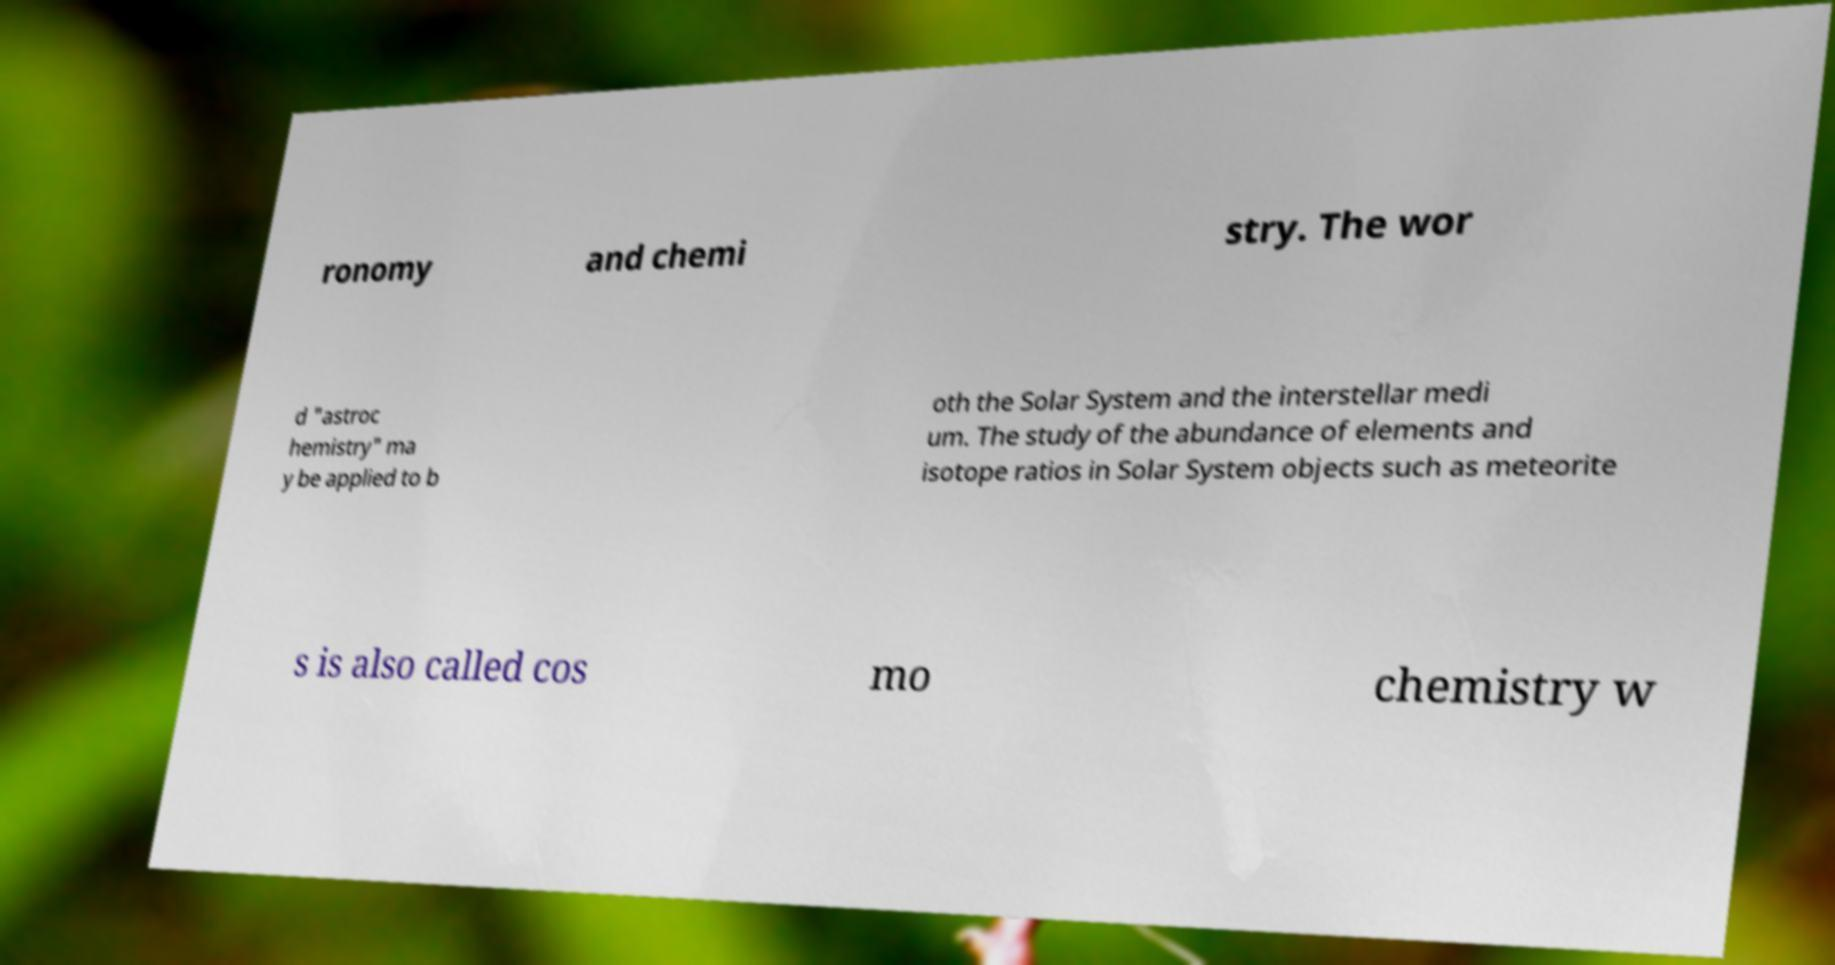Could you extract and type out the text from this image? ronomy and chemi stry. The wor d "astroc hemistry" ma y be applied to b oth the Solar System and the interstellar medi um. The study of the abundance of elements and isotope ratios in Solar System objects such as meteorite s is also called cos mo chemistry w 